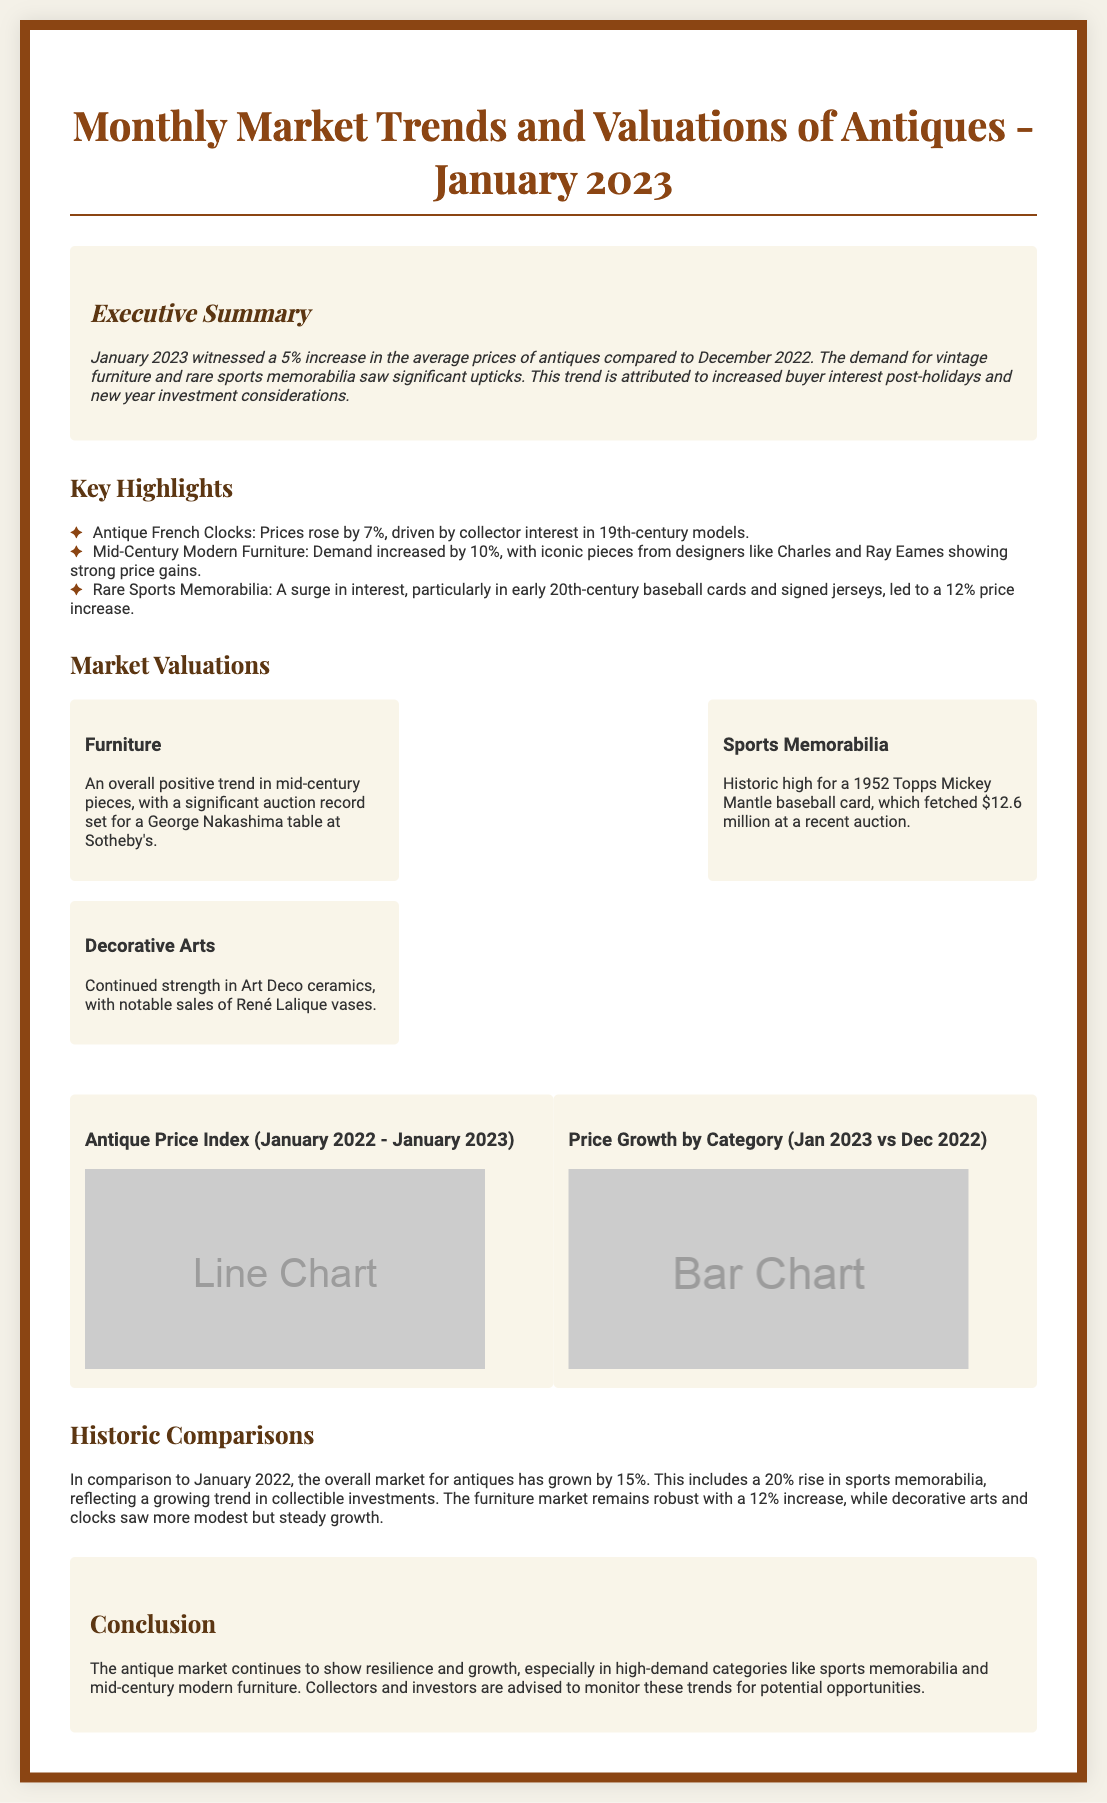What was the percentage increase in average prices of antiques in January 2023? The document states that January 2023 witnessed a 5% increase in average prices compared to December 2022.
Answer: 5% Which category saw a 12% price increase in January 2023? The document mentions that rare sports memorabilia led to a 12% price increase.
Answer: Rare Sports Memorabilia What notable auction record was set for a George Nakashima table? The document indicates there was a significant auction record but does not specify the amount.
Answer: Significant auction record How much did a 1952 Topps Mickey Mantle baseball card sell for? The document states that it fetched $12.6 million at a recent auction.
Answer: $12.6 million What percentage growth in the antique market was observed compared to January 2022? The document notes that the overall market for antiques has grown by 15% since January 2022.
Answer: 15% Which type of antiques had a 20% rise according to historic comparisons? The document specifies that sports memorabilia had a 20% rise compared to January 2022.
Answer: Sports Memorabilia What color scheme is primarily used for the document design? The document predominantly utilizes earth tones, primarily shades of brown and beige.
Answer: Earth tones What trend is indicated by increased buyer interest post-holidays? The document suggests that the trend is attributed to new year investment considerations.
Answer: New year investment considerations 